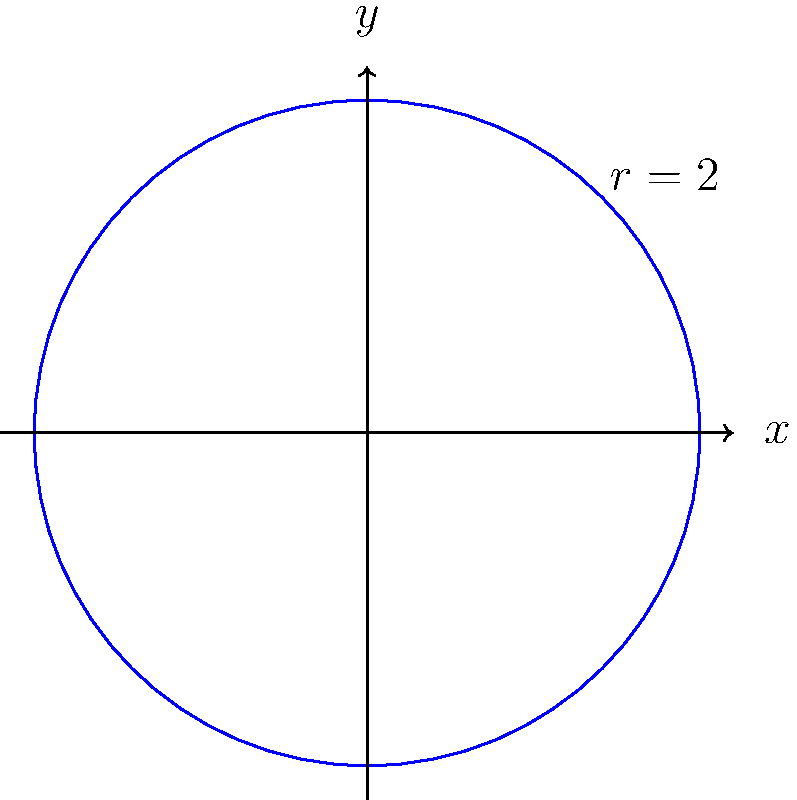As a Sensei preparing your dojo for a prestigious tournament, you need to calculate the area of a circular training mat. The mat's radius is 2 meters. Using polar coordinates and integration, determine the area of the mat. Round your answer to two decimal places. To calculate the area of the circular training mat using polar coordinates, we'll follow these steps:

1) In polar coordinates, the area of a region is given by the formula:
   $$A = \int_{0}^{2\pi} \int_{0}^{r} r \, dr \, d\theta$$

2) Here, $r$ is constant (the radius of the circle) and equal to 2 meters.

3) We can simplify our integral:
   $$A = \int_{0}^{2\pi} \int_{0}^{2} r \, dr \, d\theta$$

4) First, let's solve the inner integral:
   $$\int_{0}^{2} r \, dr = \frac{r^2}{2} \bigg|_{0}^{2} = \frac{4}{2} - 0 = 2$$

5) Now our integral becomes:
   $$A = \int_{0}^{2\pi} 2 \, d\theta$$

6) Solving this:
   $$A = 2\theta \bigg|_{0}^{2\pi} = 2(2\pi - 0) = 4\pi$$

7) Calculate the final value:
   $$A = 4\pi \approx 12.57 \text{ square meters}$$

8) Rounding to two decimal places: 12.57 square meters.

This method, rooted in the traditional mathematical approach of polar integration, allows us to honor the precision required in both karate and mathematics.
Answer: 12.57 square meters 